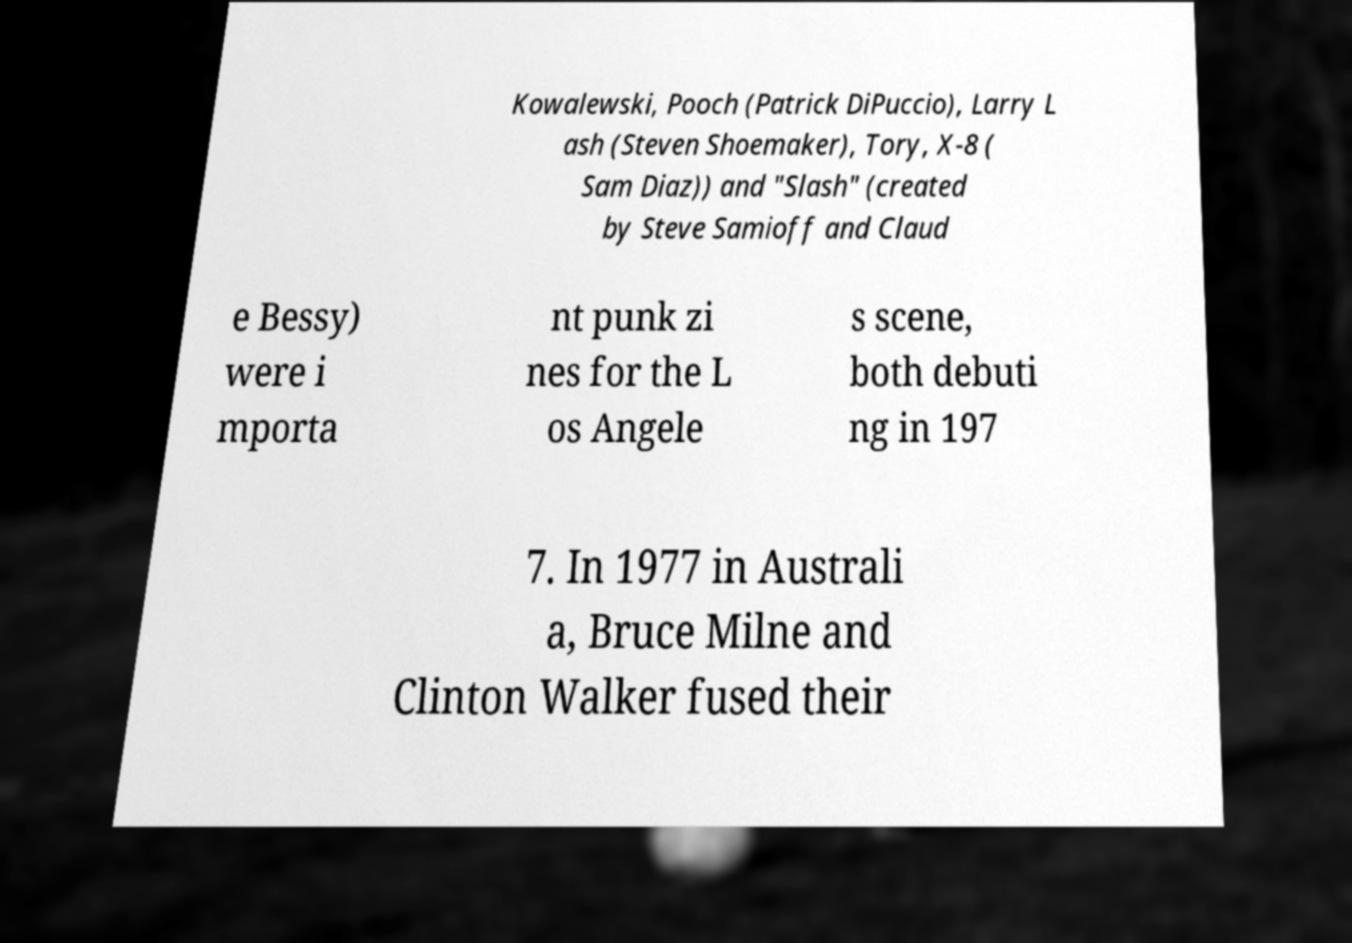Could you assist in decoding the text presented in this image and type it out clearly? Kowalewski, Pooch (Patrick DiPuccio), Larry L ash (Steven Shoemaker), Tory, X-8 ( Sam Diaz)) and "Slash" (created by Steve Samioff and Claud e Bessy) were i mporta nt punk zi nes for the L os Angele s scene, both debuti ng in 197 7. In 1977 in Australi a, Bruce Milne and Clinton Walker fused their 